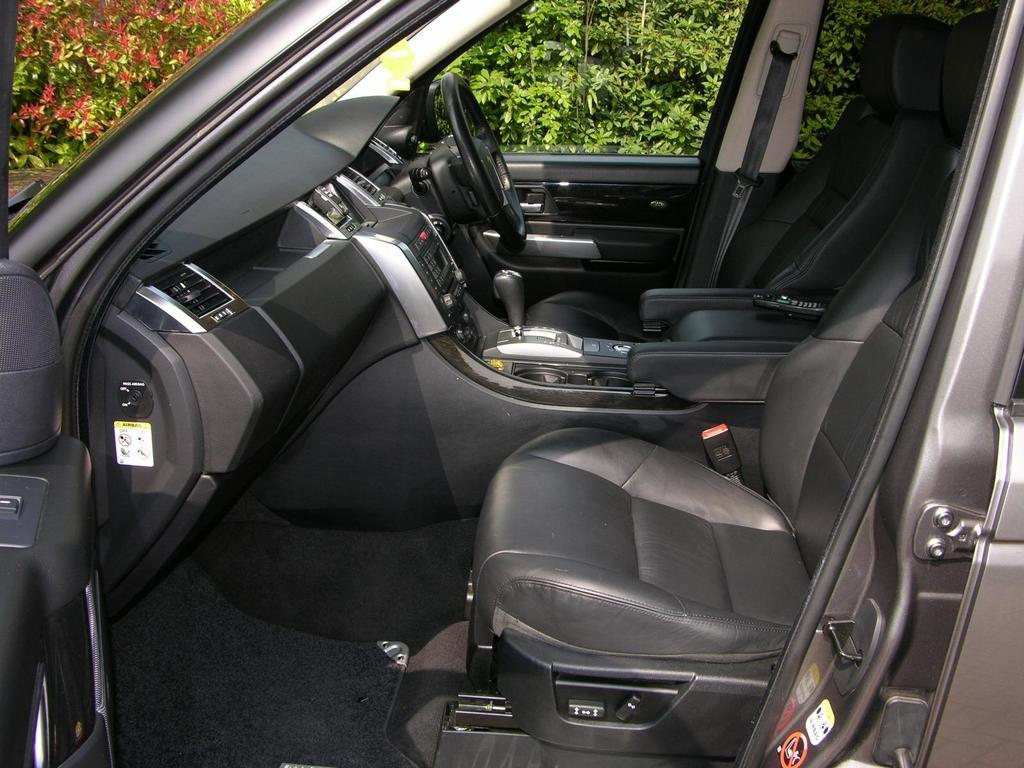What is the setting of the image? The image shows the interior of a car. What can be found at the back of the car? There are plants located at the back of the car. What country is the car driving through in the image? The image does not show the car driving through any country; it only shows the interior of the car. How many mittens are visible in the image? There are no mittens present in the image. 